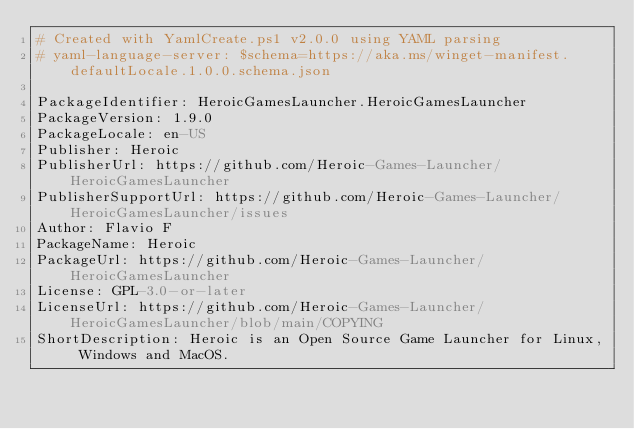<code> <loc_0><loc_0><loc_500><loc_500><_YAML_># Created with YamlCreate.ps1 v2.0.0 using YAML parsing
# yaml-language-server: $schema=https://aka.ms/winget-manifest.defaultLocale.1.0.0.schema.json

PackageIdentifier: HeroicGamesLauncher.HeroicGamesLauncher
PackageVersion: 1.9.0
PackageLocale: en-US
Publisher: Heroic
PublisherUrl: https://github.com/Heroic-Games-Launcher/HeroicGamesLauncher
PublisherSupportUrl: https://github.com/Heroic-Games-Launcher/HeroicGamesLauncher/issues
Author: Flavio F
PackageName: Heroic
PackageUrl: https://github.com/Heroic-Games-Launcher/HeroicGamesLauncher
License: GPL-3.0-or-later
LicenseUrl: https://github.com/Heroic-Games-Launcher/HeroicGamesLauncher/blob/main/COPYING
ShortDescription: Heroic is an Open Source Game Launcher for Linux, Windows and MacOS.</code> 